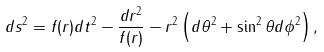<formula> <loc_0><loc_0><loc_500><loc_500>d s ^ { 2 } = f ( r ) d t ^ { 2 } - \frac { d r ^ { 2 } } { f ( r ) } - r ^ { 2 } \left ( d \theta ^ { 2 } + \sin ^ { 2 } \theta d \phi ^ { 2 } \right ) ,</formula> 